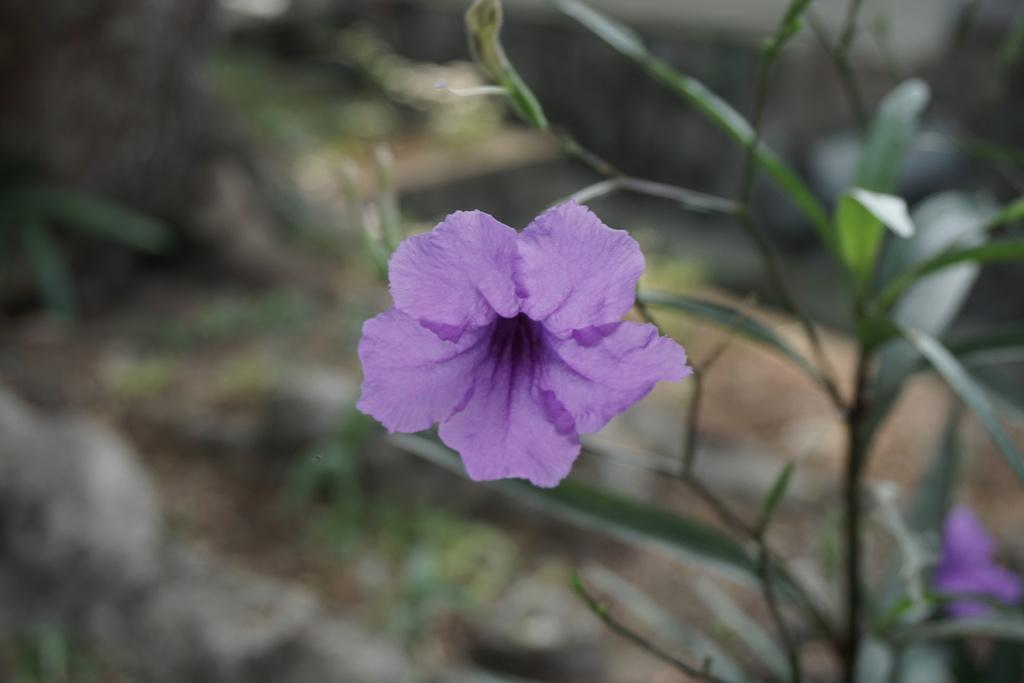What type of living organisms can be seen in the image? There are flowers on a plant in the image. Can you describe the background of the image? The background of the image is blurred. What type of rod can be seen on the side of the plant in the image? There is no rod visible on the side of the plant in the image. What pen is used to draw the flowers in the image? The image is a photograph, not a drawing, so there is no pen used to create the image. 